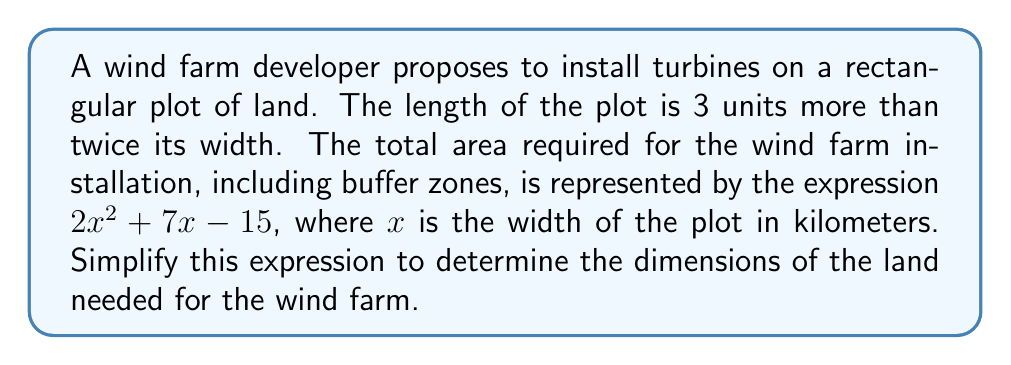Help me with this question. Let's approach this step-by-step:

1) We're given that the length is 3 units more than twice the width. If we let $x$ represent the width, then the length can be expressed as $2x + 3$.

2) The area of a rectangle is given by length times width. So the area can be expressed as:

   $A = x(2x + 3)$

3) Expanding this expression:

   $A = 2x^2 + 3x$

4) However, the given expression for the total area is $2x^2 + 7x - 15$. This suggests that there's an additional term $4x - 15$ added to account for buffer zones and other requirements.

5) To simplify this expression, we need to factor it. Let's look for common factors:

   $2x^2 + 7x - 15$

6) There are no common factors for all terms, so we'll try to factor it as a quadratic expression. We're looking for two numbers that multiply to give $2 \times (-15) = -30$ and add up to 7.

7) These numbers are 10 and -3. So we can rewrite the expression as:

   $2x^2 + 10x - 3x - 15$

8) Grouping these terms:

   $(2x^2 + 10x) + (-3x - 15)$

9) Factoring out common factors from each group:

   $2x(x + 5) - 3(x + 5)$

10) We can now factor out $(x + 5)$:

    $(x + 5)(2x - 3)$

This factored form represents the simplified expression for the land area needed for the wind farm installation.
Answer: $(x + 5)(2x - 3)$ 